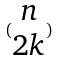Convert formula to latex. <formula><loc_0><loc_0><loc_500><loc_500>( \begin{matrix} n \\ 2 k \end{matrix} )</formula> 